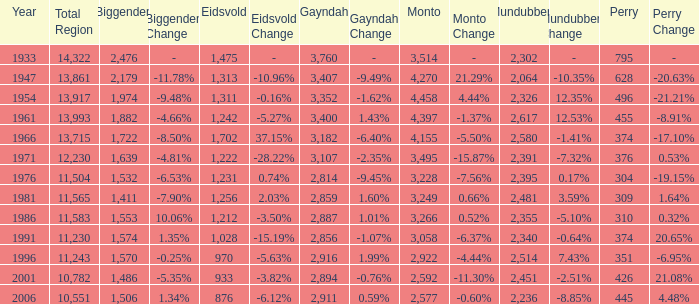What is the Total Region number of hte one that has Eidsvold at 970 and Biggenden larger than 1,570? 0.0. 